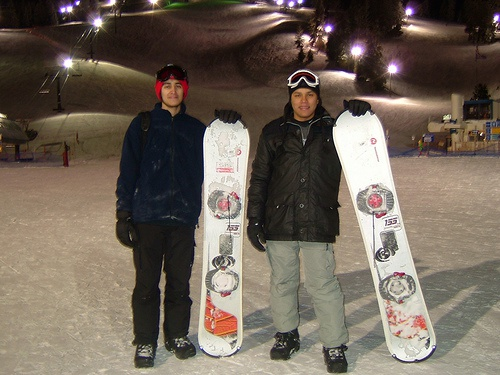Describe the objects in this image and their specific colors. I can see people in black, gray, and darkgray tones, people in black, maroon, gray, and tan tones, snowboard in black, ivory, darkgray, gray, and lightgray tones, and snowboard in black, lightgray, darkgray, and gray tones in this image. 